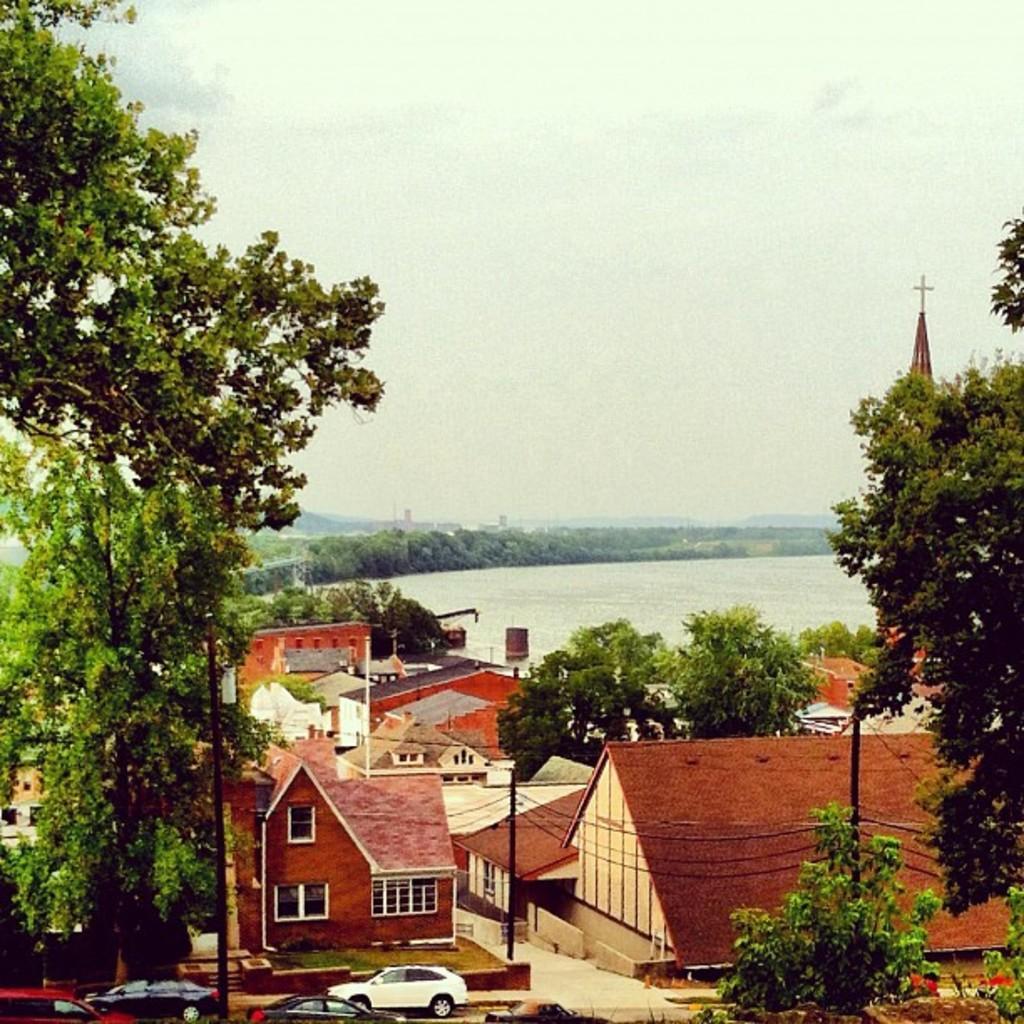How would you summarize this image in a sentence or two? In the image there are many houses and trees and in front of the houses there are few cars, behind the trees there is a water surface. 